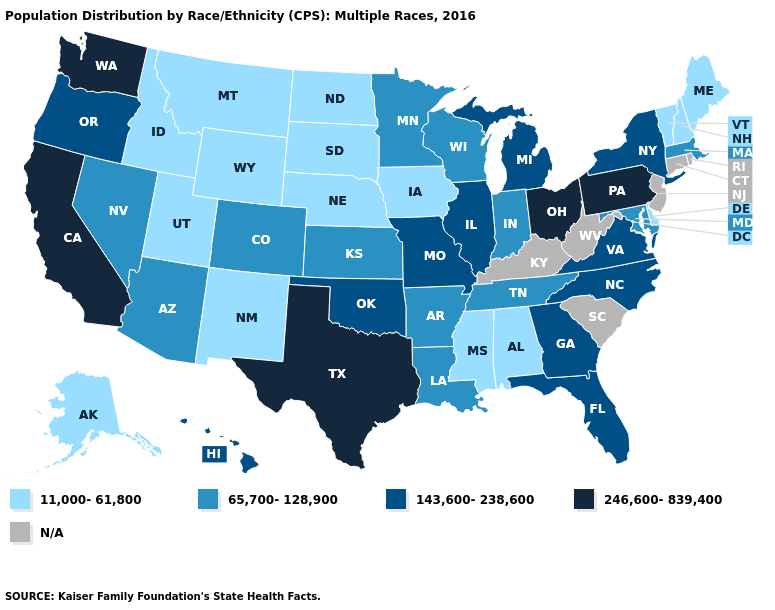Name the states that have a value in the range 11,000-61,800?
Write a very short answer. Alabama, Alaska, Delaware, Idaho, Iowa, Maine, Mississippi, Montana, Nebraska, New Hampshire, New Mexico, North Dakota, South Dakota, Utah, Vermont, Wyoming. Which states have the lowest value in the MidWest?
Answer briefly. Iowa, Nebraska, North Dakota, South Dakota. What is the value of South Carolina?
Short answer required. N/A. What is the highest value in the USA?
Write a very short answer. 246,600-839,400. Which states have the lowest value in the South?
Write a very short answer. Alabama, Delaware, Mississippi. What is the value of Kentucky?
Be succinct. N/A. Name the states that have a value in the range 11,000-61,800?
Concise answer only. Alabama, Alaska, Delaware, Idaho, Iowa, Maine, Mississippi, Montana, Nebraska, New Hampshire, New Mexico, North Dakota, South Dakota, Utah, Vermont, Wyoming. What is the value of Oklahoma?
Answer briefly. 143,600-238,600. Does the first symbol in the legend represent the smallest category?
Keep it brief. Yes. Name the states that have a value in the range 143,600-238,600?
Write a very short answer. Florida, Georgia, Hawaii, Illinois, Michigan, Missouri, New York, North Carolina, Oklahoma, Oregon, Virginia. Name the states that have a value in the range 65,700-128,900?
Short answer required. Arizona, Arkansas, Colorado, Indiana, Kansas, Louisiana, Maryland, Massachusetts, Minnesota, Nevada, Tennessee, Wisconsin. Which states hav the highest value in the West?
Answer briefly. California, Washington. Does Nebraska have the lowest value in the USA?
Concise answer only. Yes. How many symbols are there in the legend?
Write a very short answer. 5. Among the states that border North Carolina , does Tennessee have the highest value?
Write a very short answer. No. 